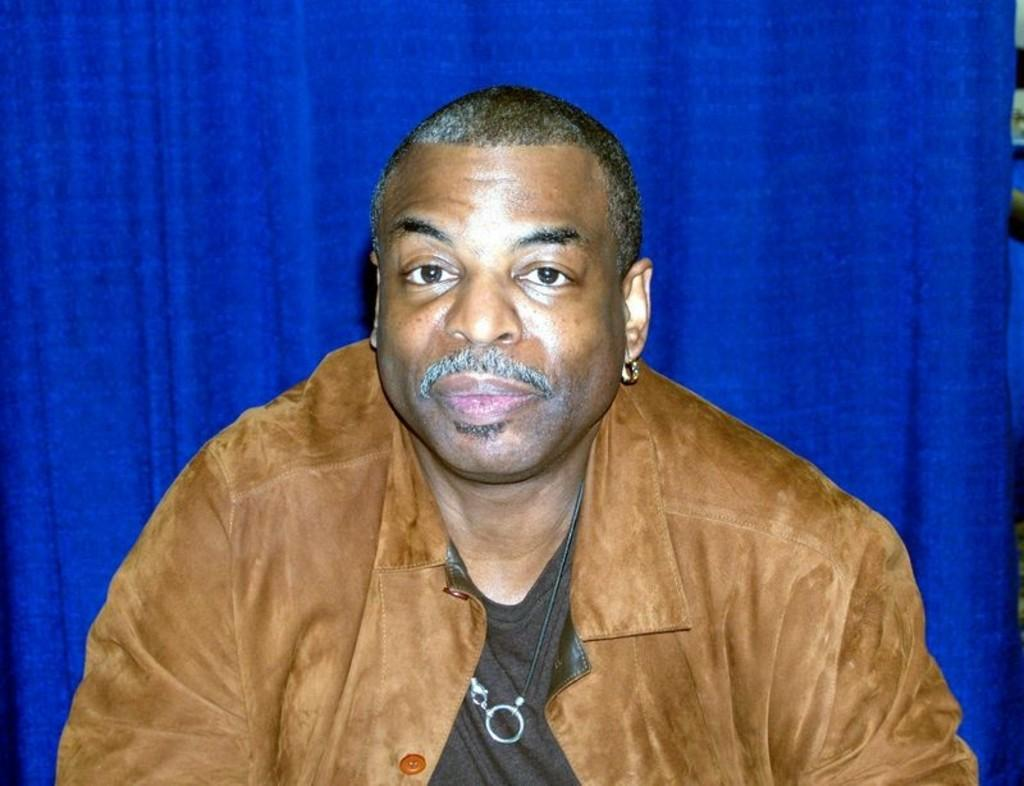Who is the main subject in the image? There is a man in the center of the image. What is the man wearing in the image? The man is wearing a jacket. What can be seen in the background of the image? There is a curtain in the background of the image. What type of leather is the man discussing with the curtain in the image? There is no leather or discussion present in the image; it only features a man wearing a jacket and a curtain in the background. 